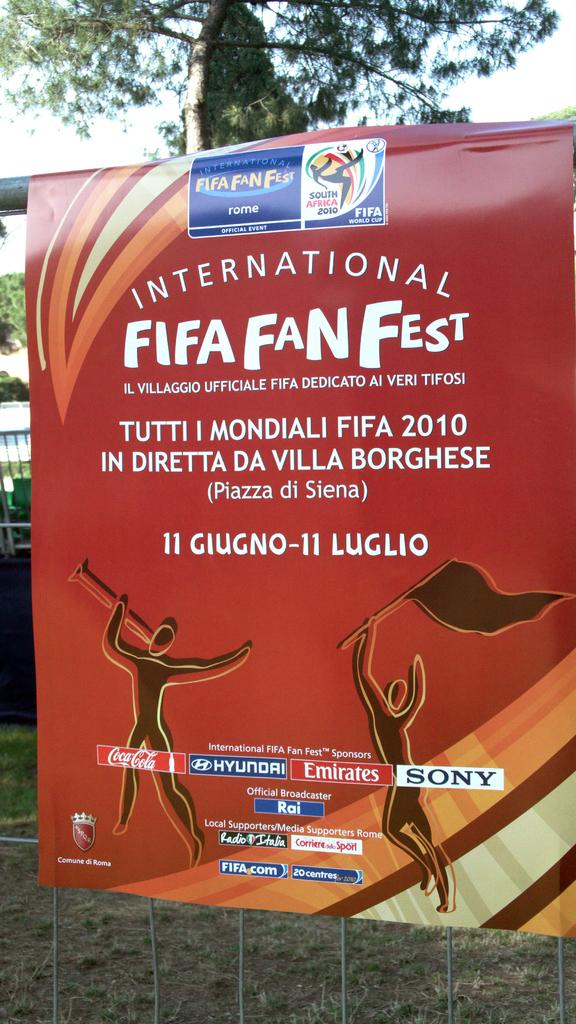<image>
Offer a succinct explanation of the picture presented. A poster displays information about Fifa Fan Fest in Italian. 